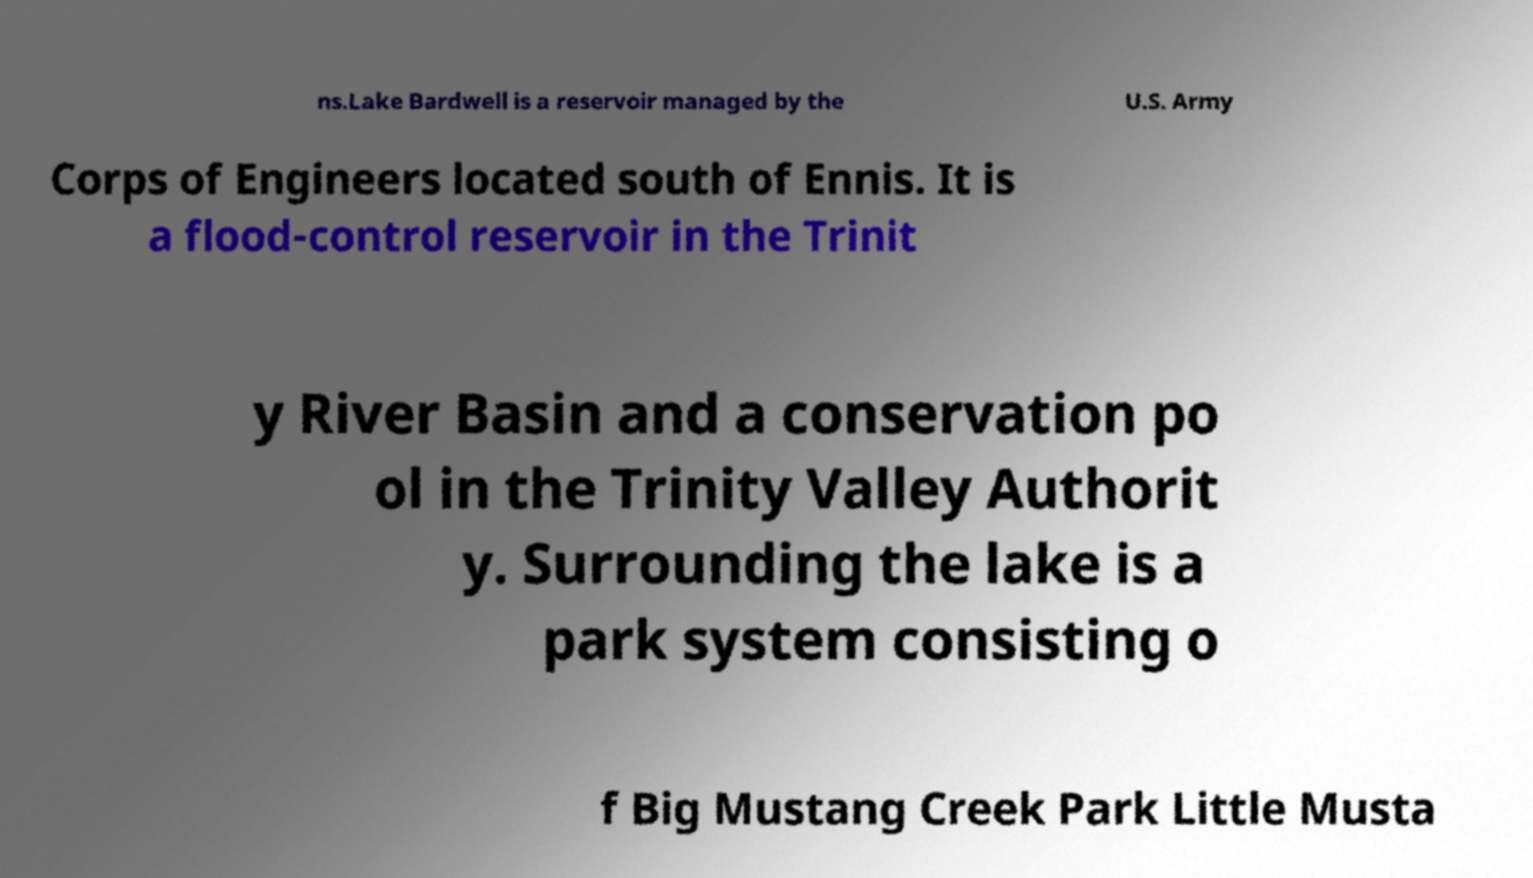Could you assist in decoding the text presented in this image and type it out clearly? ns.Lake Bardwell is a reservoir managed by the U.S. Army Corps of Engineers located south of Ennis. It is a flood-control reservoir in the Trinit y River Basin and a conservation po ol in the Trinity Valley Authorit y. Surrounding the lake is a park system consisting o f Big Mustang Creek Park Little Musta 